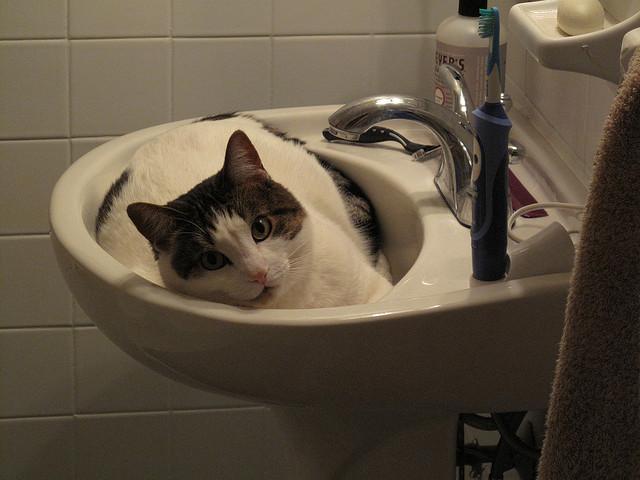What color is the cat in the sink?
Answer briefly. White. What is the cat doing?
Write a very short answer. Laying down. Where is the toothbrush?
Concise answer only. On sink. Where is the cat?
Keep it brief. Sink. What is the cat sitting on?
Quick response, please. Sink. Is the faucet turned on?
Be succinct. No. 